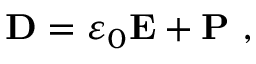<formula> <loc_0><loc_0><loc_500><loc_500>D = \varepsilon _ { 0 } E + P \ ,</formula> 